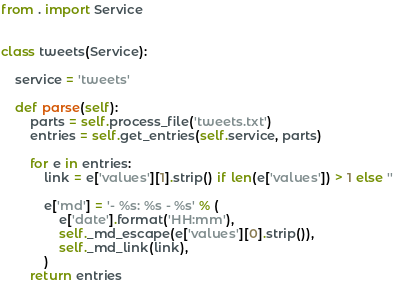Convert code to text. <code><loc_0><loc_0><loc_500><loc_500><_Python_>from . import Service


class tweets(Service):

    service = 'tweets'

    def parse(self):
        parts = self.process_file('tweets.txt')
        entries = self.get_entries(self.service, parts)

        for e in entries:
            link = e['values'][1].strip() if len(e['values']) > 1 else ''

            e['md'] = '- %s: %s - %s' % (
                e['date'].format('HH:mm'),
                self._md_escape(e['values'][0].strip()),
                self._md_link(link),
            )
        return entries
</code> 